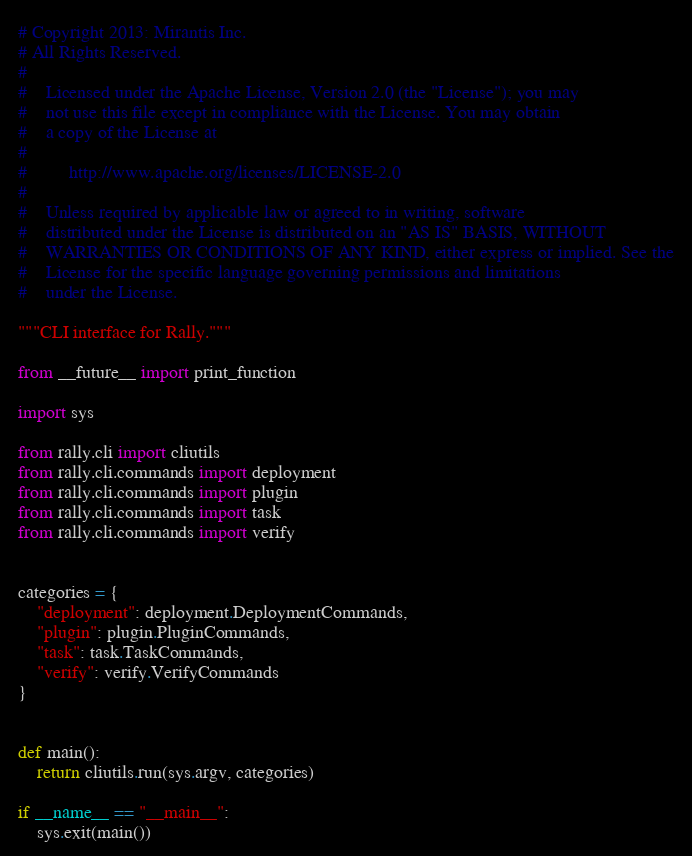Convert code to text. <code><loc_0><loc_0><loc_500><loc_500><_Python_># Copyright 2013: Mirantis Inc.
# All Rights Reserved.
#
#    Licensed under the Apache License, Version 2.0 (the "License"); you may
#    not use this file except in compliance with the License. You may obtain
#    a copy of the License at
#
#         http://www.apache.org/licenses/LICENSE-2.0
#
#    Unless required by applicable law or agreed to in writing, software
#    distributed under the License is distributed on an "AS IS" BASIS, WITHOUT
#    WARRANTIES OR CONDITIONS OF ANY KIND, either express or implied. See the
#    License for the specific language governing permissions and limitations
#    under the License.

"""CLI interface for Rally."""

from __future__ import print_function

import sys

from rally.cli import cliutils
from rally.cli.commands import deployment
from rally.cli.commands import plugin
from rally.cli.commands import task
from rally.cli.commands import verify


categories = {
    "deployment": deployment.DeploymentCommands,
    "plugin": plugin.PluginCommands,
    "task": task.TaskCommands,
    "verify": verify.VerifyCommands
}


def main():
    return cliutils.run(sys.argv, categories)

if __name__ == "__main__":
    sys.exit(main())
</code> 